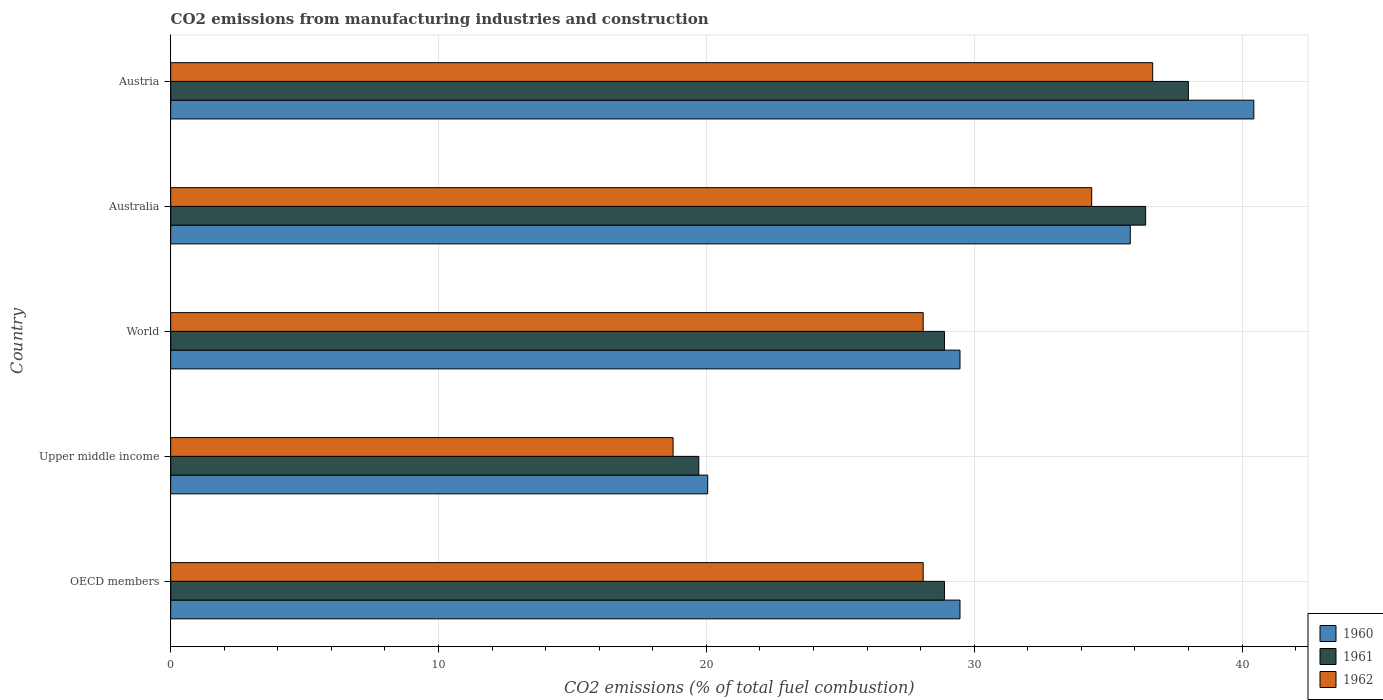How many different coloured bars are there?
Your answer should be very brief. 3. Are the number of bars per tick equal to the number of legend labels?
Ensure brevity in your answer.  Yes. Are the number of bars on each tick of the Y-axis equal?
Offer a very short reply. Yes. How many bars are there on the 2nd tick from the top?
Make the answer very short. 3. In how many cases, is the number of bars for a given country not equal to the number of legend labels?
Your response must be concise. 0. What is the amount of CO2 emitted in 1961 in Australia?
Provide a short and direct response. 36.4. Across all countries, what is the maximum amount of CO2 emitted in 1961?
Keep it short and to the point. 37.99. Across all countries, what is the minimum amount of CO2 emitted in 1961?
Ensure brevity in your answer.  19.72. In which country was the amount of CO2 emitted in 1960 minimum?
Your answer should be very brief. Upper middle income. What is the total amount of CO2 emitted in 1960 in the graph?
Keep it short and to the point. 155.25. What is the difference between the amount of CO2 emitted in 1961 in Australia and that in Austria?
Ensure brevity in your answer.  -1.6. What is the difference between the amount of CO2 emitted in 1960 in Australia and the amount of CO2 emitted in 1961 in Austria?
Provide a succinct answer. -2.17. What is the average amount of CO2 emitted in 1960 per country?
Make the answer very short. 31.05. What is the difference between the amount of CO2 emitted in 1962 and amount of CO2 emitted in 1960 in Australia?
Your response must be concise. -1.44. What is the ratio of the amount of CO2 emitted in 1962 in Upper middle income to that in World?
Offer a very short reply. 0.67. Is the amount of CO2 emitted in 1960 in OECD members less than that in Upper middle income?
Your answer should be very brief. No. What is the difference between the highest and the second highest amount of CO2 emitted in 1962?
Make the answer very short. 2.28. What is the difference between the highest and the lowest amount of CO2 emitted in 1960?
Make the answer very short. 20.39. What does the 1st bar from the bottom in World represents?
Your answer should be very brief. 1960. Is it the case that in every country, the sum of the amount of CO2 emitted in 1962 and amount of CO2 emitted in 1961 is greater than the amount of CO2 emitted in 1960?
Give a very brief answer. Yes. How many bars are there?
Give a very brief answer. 15. Are the values on the major ticks of X-axis written in scientific E-notation?
Make the answer very short. No. Does the graph contain any zero values?
Make the answer very short. No. Where does the legend appear in the graph?
Your answer should be very brief. Bottom right. What is the title of the graph?
Your response must be concise. CO2 emissions from manufacturing industries and construction. Does "1960" appear as one of the legend labels in the graph?
Your response must be concise. Yes. What is the label or title of the X-axis?
Your response must be concise. CO2 emissions (% of total fuel combustion). What is the label or title of the Y-axis?
Give a very brief answer. Country. What is the CO2 emissions (% of total fuel combustion) of 1960 in OECD members?
Your response must be concise. 29.47. What is the CO2 emissions (% of total fuel combustion) in 1961 in OECD members?
Your answer should be very brief. 28.89. What is the CO2 emissions (% of total fuel combustion) of 1962 in OECD members?
Provide a succinct answer. 28.09. What is the CO2 emissions (% of total fuel combustion) of 1960 in Upper middle income?
Your answer should be compact. 20.05. What is the CO2 emissions (% of total fuel combustion) of 1961 in Upper middle income?
Give a very brief answer. 19.72. What is the CO2 emissions (% of total fuel combustion) of 1962 in Upper middle income?
Make the answer very short. 18.76. What is the CO2 emissions (% of total fuel combustion) of 1960 in World?
Provide a short and direct response. 29.47. What is the CO2 emissions (% of total fuel combustion) of 1961 in World?
Give a very brief answer. 28.89. What is the CO2 emissions (% of total fuel combustion) of 1962 in World?
Your response must be concise. 28.09. What is the CO2 emissions (% of total fuel combustion) of 1960 in Australia?
Give a very brief answer. 35.83. What is the CO2 emissions (% of total fuel combustion) of 1961 in Australia?
Ensure brevity in your answer.  36.4. What is the CO2 emissions (% of total fuel combustion) of 1962 in Australia?
Provide a short and direct response. 34.39. What is the CO2 emissions (% of total fuel combustion) of 1960 in Austria?
Your answer should be compact. 40.44. What is the CO2 emissions (% of total fuel combustion) in 1961 in Austria?
Ensure brevity in your answer.  37.99. What is the CO2 emissions (% of total fuel combustion) of 1962 in Austria?
Make the answer very short. 36.66. Across all countries, what is the maximum CO2 emissions (% of total fuel combustion) in 1960?
Your answer should be compact. 40.44. Across all countries, what is the maximum CO2 emissions (% of total fuel combustion) of 1961?
Offer a terse response. 37.99. Across all countries, what is the maximum CO2 emissions (% of total fuel combustion) in 1962?
Ensure brevity in your answer.  36.66. Across all countries, what is the minimum CO2 emissions (% of total fuel combustion) of 1960?
Offer a very short reply. 20.05. Across all countries, what is the minimum CO2 emissions (% of total fuel combustion) in 1961?
Give a very brief answer. 19.72. Across all countries, what is the minimum CO2 emissions (% of total fuel combustion) of 1962?
Your answer should be very brief. 18.76. What is the total CO2 emissions (% of total fuel combustion) of 1960 in the graph?
Give a very brief answer. 155.25. What is the total CO2 emissions (% of total fuel combustion) of 1961 in the graph?
Ensure brevity in your answer.  151.89. What is the total CO2 emissions (% of total fuel combustion) of 1962 in the graph?
Provide a short and direct response. 145.99. What is the difference between the CO2 emissions (% of total fuel combustion) of 1960 in OECD members and that in Upper middle income?
Your response must be concise. 9.42. What is the difference between the CO2 emissions (% of total fuel combustion) of 1961 in OECD members and that in Upper middle income?
Your answer should be compact. 9.17. What is the difference between the CO2 emissions (% of total fuel combustion) of 1962 in OECD members and that in Upper middle income?
Your answer should be very brief. 9.34. What is the difference between the CO2 emissions (% of total fuel combustion) of 1960 in OECD members and that in World?
Ensure brevity in your answer.  0. What is the difference between the CO2 emissions (% of total fuel combustion) in 1961 in OECD members and that in World?
Offer a very short reply. 0. What is the difference between the CO2 emissions (% of total fuel combustion) of 1960 in OECD members and that in Australia?
Give a very brief answer. -6.36. What is the difference between the CO2 emissions (% of total fuel combustion) in 1961 in OECD members and that in Australia?
Offer a very short reply. -7.51. What is the difference between the CO2 emissions (% of total fuel combustion) of 1962 in OECD members and that in Australia?
Offer a terse response. -6.29. What is the difference between the CO2 emissions (% of total fuel combustion) in 1960 in OECD members and that in Austria?
Make the answer very short. -10.97. What is the difference between the CO2 emissions (% of total fuel combustion) of 1961 in OECD members and that in Austria?
Ensure brevity in your answer.  -9.11. What is the difference between the CO2 emissions (% of total fuel combustion) of 1962 in OECD members and that in Austria?
Provide a succinct answer. -8.57. What is the difference between the CO2 emissions (% of total fuel combustion) in 1960 in Upper middle income and that in World?
Your response must be concise. -9.42. What is the difference between the CO2 emissions (% of total fuel combustion) in 1961 in Upper middle income and that in World?
Offer a terse response. -9.17. What is the difference between the CO2 emissions (% of total fuel combustion) in 1962 in Upper middle income and that in World?
Provide a succinct answer. -9.34. What is the difference between the CO2 emissions (% of total fuel combustion) in 1960 in Upper middle income and that in Australia?
Provide a succinct answer. -15.78. What is the difference between the CO2 emissions (% of total fuel combustion) in 1961 in Upper middle income and that in Australia?
Provide a short and direct response. -16.68. What is the difference between the CO2 emissions (% of total fuel combustion) of 1962 in Upper middle income and that in Australia?
Provide a short and direct response. -15.63. What is the difference between the CO2 emissions (% of total fuel combustion) in 1960 in Upper middle income and that in Austria?
Your answer should be compact. -20.39. What is the difference between the CO2 emissions (% of total fuel combustion) of 1961 in Upper middle income and that in Austria?
Your answer should be very brief. -18.28. What is the difference between the CO2 emissions (% of total fuel combustion) of 1962 in Upper middle income and that in Austria?
Offer a very short reply. -17.9. What is the difference between the CO2 emissions (% of total fuel combustion) in 1960 in World and that in Australia?
Ensure brevity in your answer.  -6.36. What is the difference between the CO2 emissions (% of total fuel combustion) in 1961 in World and that in Australia?
Your answer should be very brief. -7.51. What is the difference between the CO2 emissions (% of total fuel combustion) of 1962 in World and that in Australia?
Your answer should be very brief. -6.29. What is the difference between the CO2 emissions (% of total fuel combustion) of 1960 in World and that in Austria?
Your response must be concise. -10.97. What is the difference between the CO2 emissions (% of total fuel combustion) of 1961 in World and that in Austria?
Your answer should be very brief. -9.11. What is the difference between the CO2 emissions (% of total fuel combustion) of 1962 in World and that in Austria?
Provide a short and direct response. -8.57. What is the difference between the CO2 emissions (% of total fuel combustion) in 1960 in Australia and that in Austria?
Offer a terse response. -4.61. What is the difference between the CO2 emissions (% of total fuel combustion) in 1961 in Australia and that in Austria?
Ensure brevity in your answer.  -1.6. What is the difference between the CO2 emissions (% of total fuel combustion) in 1962 in Australia and that in Austria?
Provide a succinct answer. -2.28. What is the difference between the CO2 emissions (% of total fuel combustion) in 1960 in OECD members and the CO2 emissions (% of total fuel combustion) in 1961 in Upper middle income?
Your response must be concise. 9.75. What is the difference between the CO2 emissions (% of total fuel combustion) in 1960 in OECD members and the CO2 emissions (% of total fuel combustion) in 1962 in Upper middle income?
Your response must be concise. 10.71. What is the difference between the CO2 emissions (% of total fuel combustion) of 1961 in OECD members and the CO2 emissions (% of total fuel combustion) of 1962 in Upper middle income?
Provide a short and direct response. 10.13. What is the difference between the CO2 emissions (% of total fuel combustion) of 1960 in OECD members and the CO2 emissions (% of total fuel combustion) of 1961 in World?
Offer a terse response. 0.58. What is the difference between the CO2 emissions (% of total fuel combustion) in 1960 in OECD members and the CO2 emissions (% of total fuel combustion) in 1962 in World?
Provide a succinct answer. 1.38. What is the difference between the CO2 emissions (% of total fuel combustion) of 1961 in OECD members and the CO2 emissions (% of total fuel combustion) of 1962 in World?
Make the answer very short. 0.79. What is the difference between the CO2 emissions (% of total fuel combustion) in 1960 in OECD members and the CO2 emissions (% of total fuel combustion) in 1961 in Australia?
Provide a succinct answer. -6.93. What is the difference between the CO2 emissions (% of total fuel combustion) of 1960 in OECD members and the CO2 emissions (% of total fuel combustion) of 1962 in Australia?
Provide a short and direct response. -4.92. What is the difference between the CO2 emissions (% of total fuel combustion) in 1961 in OECD members and the CO2 emissions (% of total fuel combustion) in 1962 in Australia?
Keep it short and to the point. -5.5. What is the difference between the CO2 emissions (% of total fuel combustion) in 1960 in OECD members and the CO2 emissions (% of total fuel combustion) in 1961 in Austria?
Offer a terse response. -8.53. What is the difference between the CO2 emissions (% of total fuel combustion) in 1960 in OECD members and the CO2 emissions (% of total fuel combustion) in 1962 in Austria?
Make the answer very short. -7.19. What is the difference between the CO2 emissions (% of total fuel combustion) of 1961 in OECD members and the CO2 emissions (% of total fuel combustion) of 1962 in Austria?
Your response must be concise. -7.77. What is the difference between the CO2 emissions (% of total fuel combustion) in 1960 in Upper middle income and the CO2 emissions (% of total fuel combustion) in 1961 in World?
Ensure brevity in your answer.  -8.84. What is the difference between the CO2 emissions (% of total fuel combustion) in 1960 in Upper middle income and the CO2 emissions (% of total fuel combustion) in 1962 in World?
Give a very brief answer. -8.04. What is the difference between the CO2 emissions (% of total fuel combustion) of 1961 in Upper middle income and the CO2 emissions (% of total fuel combustion) of 1962 in World?
Keep it short and to the point. -8.38. What is the difference between the CO2 emissions (% of total fuel combustion) in 1960 in Upper middle income and the CO2 emissions (% of total fuel combustion) in 1961 in Australia?
Keep it short and to the point. -16.35. What is the difference between the CO2 emissions (% of total fuel combustion) of 1960 in Upper middle income and the CO2 emissions (% of total fuel combustion) of 1962 in Australia?
Keep it short and to the point. -14.34. What is the difference between the CO2 emissions (% of total fuel combustion) of 1961 in Upper middle income and the CO2 emissions (% of total fuel combustion) of 1962 in Australia?
Your answer should be very brief. -14.67. What is the difference between the CO2 emissions (% of total fuel combustion) of 1960 in Upper middle income and the CO2 emissions (% of total fuel combustion) of 1961 in Austria?
Your answer should be compact. -17.95. What is the difference between the CO2 emissions (% of total fuel combustion) in 1960 in Upper middle income and the CO2 emissions (% of total fuel combustion) in 1962 in Austria?
Offer a terse response. -16.61. What is the difference between the CO2 emissions (% of total fuel combustion) in 1961 in Upper middle income and the CO2 emissions (% of total fuel combustion) in 1962 in Austria?
Make the answer very short. -16.95. What is the difference between the CO2 emissions (% of total fuel combustion) in 1960 in World and the CO2 emissions (% of total fuel combustion) in 1961 in Australia?
Offer a terse response. -6.93. What is the difference between the CO2 emissions (% of total fuel combustion) of 1960 in World and the CO2 emissions (% of total fuel combustion) of 1962 in Australia?
Keep it short and to the point. -4.92. What is the difference between the CO2 emissions (% of total fuel combustion) of 1961 in World and the CO2 emissions (% of total fuel combustion) of 1962 in Australia?
Provide a short and direct response. -5.5. What is the difference between the CO2 emissions (% of total fuel combustion) of 1960 in World and the CO2 emissions (% of total fuel combustion) of 1961 in Austria?
Your response must be concise. -8.53. What is the difference between the CO2 emissions (% of total fuel combustion) of 1960 in World and the CO2 emissions (% of total fuel combustion) of 1962 in Austria?
Provide a short and direct response. -7.19. What is the difference between the CO2 emissions (% of total fuel combustion) in 1961 in World and the CO2 emissions (% of total fuel combustion) in 1962 in Austria?
Your answer should be very brief. -7.77. What is the difference between the CO2 emissions (% of total fuel combustion) in 1960 in Australia and the CO2 emissions (% of total fuel combustion) in 1961 in Austria?
Provide a succinct answer. -2.17. What is the difference between the CO2 emissions (% of total fuel combustion) of 1960 in Australia and the CO2 emissions (% of total fuel combustion) of 1962 in Austria?
Give a very brief answer. -0.84. What is the difference between the CO2 emissions (% of total fuel combustion) in 1961 in Australia and the CO2 emissions (% of total fuel combustion) in 1962 in Austria?
Offer a very short reply. -0.26. What is the average CO2 emissions (% of total fuel combustion) in 1960 per country?
Ensure brevity in your answer.  31.05. What is the average CO2 emissions (% of total fuel combustion) of 1961 per country?
Offer a terse response. 30.38. What is the average CO2 emissions (% of total fuel combustion) in 1962 per country?
Offer a very short reply. 29.2. What is the difference between the CO2 emissions (% of total fuel combustion) in 1960 and CO2 emissions (% of total fuel combustion) in 1961 in OECD members?
Your answer should be very brief. 0.58. What is the difference between the CO2 emissions (% of total fuel combustion) in 1960 and CO2 emissions (% of total fuel combustion) in 1962 in OECD members?
Keep it short and to the point. 1.38. What is the difference between the CO2 emissions (% of total fuel combustion) in 1961 and CO2 emissions (% of total fuel combustion) in 1962 in OECD members?
Keep it short and to the point. 0.79. What is the difference between the CO2 emissions (% of total fuel combustion) in 1960 and CO2 emissions (% of total fuel combustion) in 1961 in Upper middle income?
Your answer should be very brief. 0.33. What is the difference between the CO2 emissions (% of total fuel combustion) in 1960 and CO2 emissions (% of total fuel combustion) in 1962 in Upper middle income?
Provide a short and direct response. 1.29. What is the difference between the CO2 emissions (% of total fuel combustion) of 1961 and CO2 emissions (% of total fuel combustion) of 1962 in Upper middle income?
Your response must be concise. 0.96. What is the difference between the CO2 emissions (% of total fuel combustion) of 1960 and CO2 emissions (% of total fuel combustion) of 1961 in World?
Your response must be concise. 0.58. What is the difference between the CO2 emissions (% of total fuel combustion) of 1960 and CO2 emissions (% of total fuel combustion) of 1962 in World?
Provide a short and direct response. 1.38. What is the difference between the CO2 emissions (% of total fuel combustion) of 1961 and CO2 emissions (% of total fuel combustion) of 1962 in World?
Provide a short and direct response. 0.79. What is the difference between the CO2 emissions (% of total fuel combustion) of 1960 and CO2 emissions (% of total fuel combustion) of 1961 in Australia?
Offer a terse response. -0.57. What is the difference between the CO2 emissions (% of total fuel combustion) of 1960 and CO2 emissions (% of total fuel combustion) of 1962 in Australia?
Make the answer very short. 1.44. What is the difference between the CO2 emissions (% of total fuel combustion) in 1961 and CO2 emissions (% of total fuel combustion) in 1962 in Australia?
Your answer should be very brief. 2.01. What is the difference between the CO2 emissions (% of total fuel combustion) of 1960 and CO2 emissions (% of total fuel combustion) of 1961 in Austria?
Your answer should be very brief. 2.44. What is the difference between the CO2 emissions (% of total fuel combustion) of 1960 and CO2 emissions (% of total fuel combustion) of 1962 in Austria?
Offer a very short reply. 3.78. What is the difference between the CO2 emissions (% of total fuel combustion) of 1961 and CO2 emissions (% of total fuel combustion) of 1962 in Austria?
Your answer should be compact. 1.33. What is the ratio of the CO2 emissions (% of total fuel combustion) in 1960 in OECD members to that in Upper middle income?
Keep it short and to the point. 1.47. What is the ratio of the CO2 emissions (% of total fuel combustion) in 1961 in OECD members to that in Upper middle income?
Provide a short and direct response. 1.47. What is the ratio of the CO2 emissions (% of total fuel combustion) of 1962 in OECD members to that in Upper middle income?
Give a very brief answer. 1.5. What is the ratio of the CO2 emissions (% of total fuel combustion) in 1960 in OECD members to that in World?
Provide a short and direct response. 1. What is the ratio of the CO2 emissions (% of total fuel combustion) of 1962 in OECD members to that in World?
Your answer should be very brief. 1. What is the ratio of the CO2 emissions (% of total fuel combustion) of 1960 in OECD members to that in Australia?
Provide a short and direct response. 0.82. What is the ratio of the CO2 emissions (% of total fuel combustion) of 1961 in OECD members to that in Australia?
Keep it short and to the point. 0.79. What is the ratio of the CO2 emissions (% of total fuel combustion) of 1962 in OECD members to that in Australia?
Your response must be concise. 0.82. What is the ratio of the CO2 emissions (% of total fuel combustion) in 1960 in OECD members to that in Austria?
Provide a succinct answer. 0.73. What is the ratio of the CO2 emissions (% of total fuel combustion) of 1961 in OECD members to that in Austria?
Your response must be concise. 0.76. What is the ratio of the CO2 emissions (% of total fuel combustion) of 1962 in OECD members to that in Austria?
Give a very brief answer. 0.77. What is the ratio of the CO2 emissions (% of total fuel combustion) of 1960 in Upper middle income to that in World?
Offer a very short reply. 0.68. What is the ratio of the CO2 emissions (% of total fuel combustion) in 1961 in Upper middle income to that in World?
Give a very brief answer. 0.68. What is the ratio of the CO2 emissions (% of total fuel combustion) in 1962 in Upper middle income to that in World?
Give a very brief answer. 0.67. What is the ratio of the CO2 emissions (% of total fuel combustion) in 1960 in Upper middle income to that in Australia?
Make the answer very short. 0.56. What is the ratio of the CO2 emissions (% of total fuel combustion) of 1961 in Upper middle income to that in Australia?
Offer a terse response. 0.54. What is the ratio of the CO2 emissions (% of total fuel combustion) in 1962 in Upper middle income to that in Australia?
Provide a succinct answer. 0.55. What is the ratio of the CO2 emissions (% of total fuel combustion) in 1960 in Upper middle income to that in Austria?
Your answer should be very brief. 0.5. What is the ratio of the CO2 emissions (% of total fuel combustion) in 1961 in Upper middle income to that in Austria?
Your answer should be very brief. 0.52. What is the ratio of the CO2 emissions (% of total fuel combustion) of 1962 in Upper middle income to that in Austria?
Offer a terse response. 0.51. What is the ratio of the CO2 emissions (% of total fuel combustion) in 1960 in World to that in Australia?
Your answer should be compact. 0.82. What is the ratio of the CO2 emissions (% of total fuel combustion) in 1961 in World to that in Australia?
Your answer should be compact. 0.79. What is the ratio of the CO2 emissions (% of total fuel combustion) in 1962 in World to that in Australia?
Ensure brevity in your answer.  0.82. What is the ratio of the CO2 emissions (% of total fuel combustion) of 1960 in World to that in Austria?
Make the answer very short. 0.73. What is the ratio of the CO2 emissions (% of total fuel combustion) in 1961 in World to that in Austria?
Offer a terse response. 0.76. What is the ratio of the CO2 emissions (% of total fuel combustion) in 1962 in World to that in Austria?
Keep it short and to the point. 0.77. What is the ratio of the CO2 emissions (% of total fuel combustion) of 1960 in Australia to that in Austria?
Make the answer very short. 0.89. What is the ratio of the CO2 emissions (% of total fuel combustion) of 1961 in Australia to that in Austria?
Provide a short and direct response. 0.96. What is the ratio of the CO2 emissions (% of total fuel combustion) of 1962 in Australia to that in Austria?
Your response must be concise. 0.94. What is the difference between the highest and the second highest CO2 emissions (% of total fuel combustion) of 1960?
Make the answer very short. 4.61. What is the difference between the highest and the second highest CO2 emissions (% of total fuel combustion) in 1961?
Make the answer very short. 1.6. What is the difference between the highest and the second highest CO2 emissions (% of total fuel combustion) of 1962?
Your answer should be very brief. 2.28. What is the difference between the highest and the lowest CO2 emissions (% of total fuel combustion) of 1960?
Keep it short and to the point. 20.39. What is the difference between the highest and the lowest CO2 emissions (% of total fuel combustion) of 1961?
Give a very brief answer. 18.28. What is the difference between the highest and the lowest CO2 emissions (% of total fuel combustion) in 1962?
Ensure brevity in your answer.  17.9. 